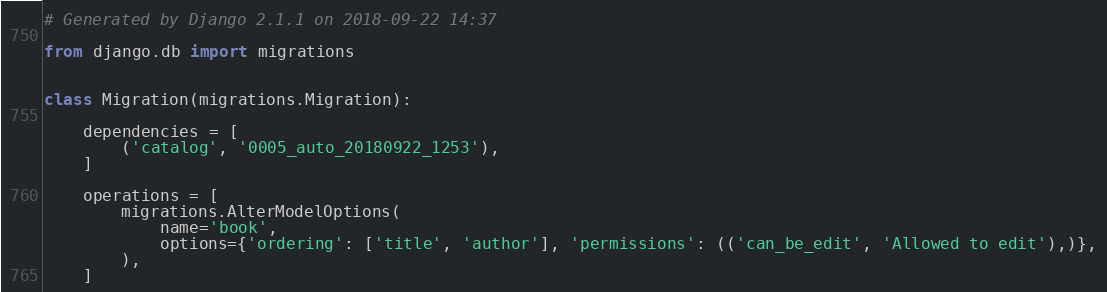<code> <loc_0><loc_0><loc_500><loc_500><_Python_># Generated by Django 2.1.1 on 2018-09-22 14:37

from django.db import migrations


class Migration(migrations.Migration):

    dependencies = [
        ('catalog', '0005_auto_20180922_1253'),
    ]

    operations = [
        migrations.AlterModelOptions(
            name='book',
            options={'ordering': ['title', 'author'], 'permissions': (('can_be_edit', 'Allowed to edit'),)},
        ),
    ]
</code> 